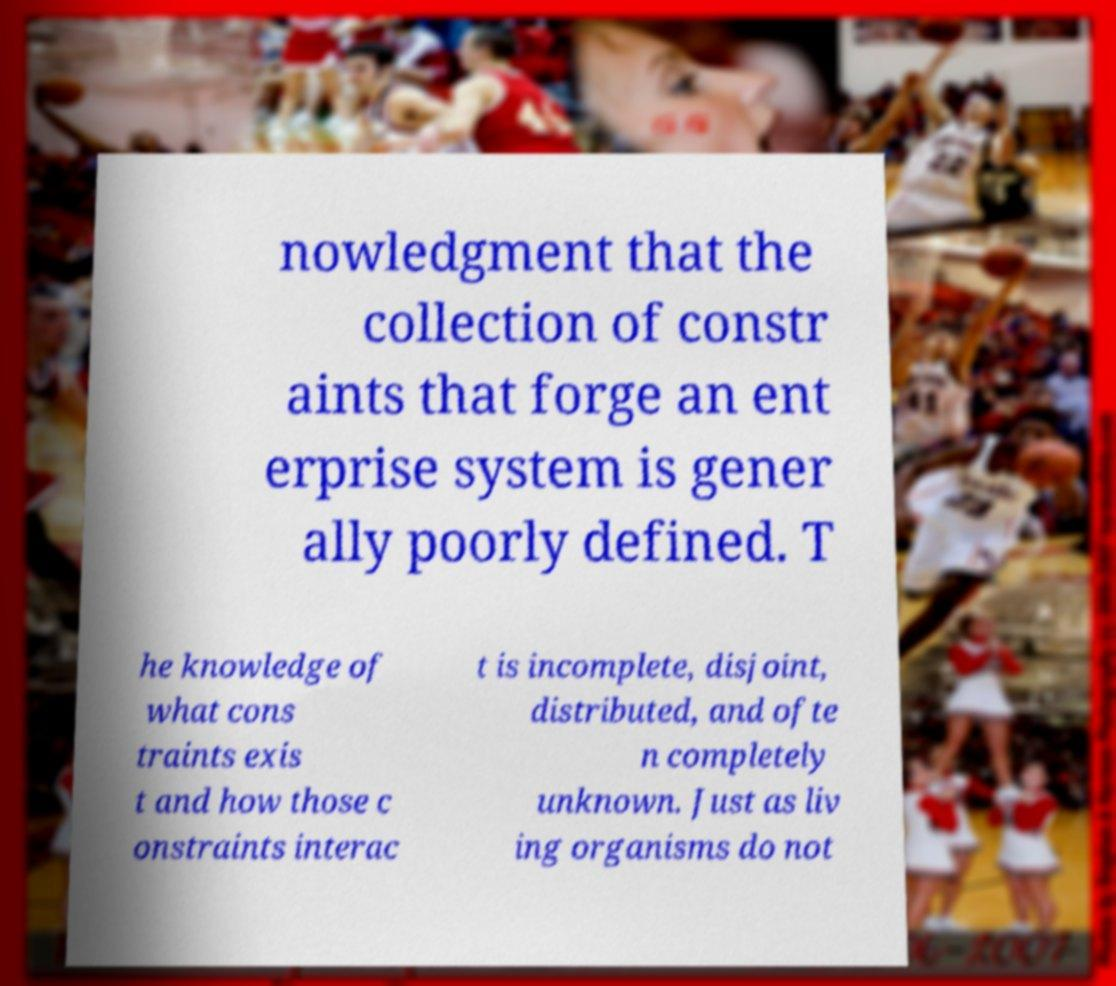For documentation purposes, I need the text within this image transcribed. Could you provide that? nowledgment that the collection of constr aints that forge an ent erprise system is gener ally poorly defined. T he knowledge of what cons traints exis t and how those c onstraints interac t is incomplete, disjoint, distributed, and ofte n completely unknown. Just as liv ing organisms do not 